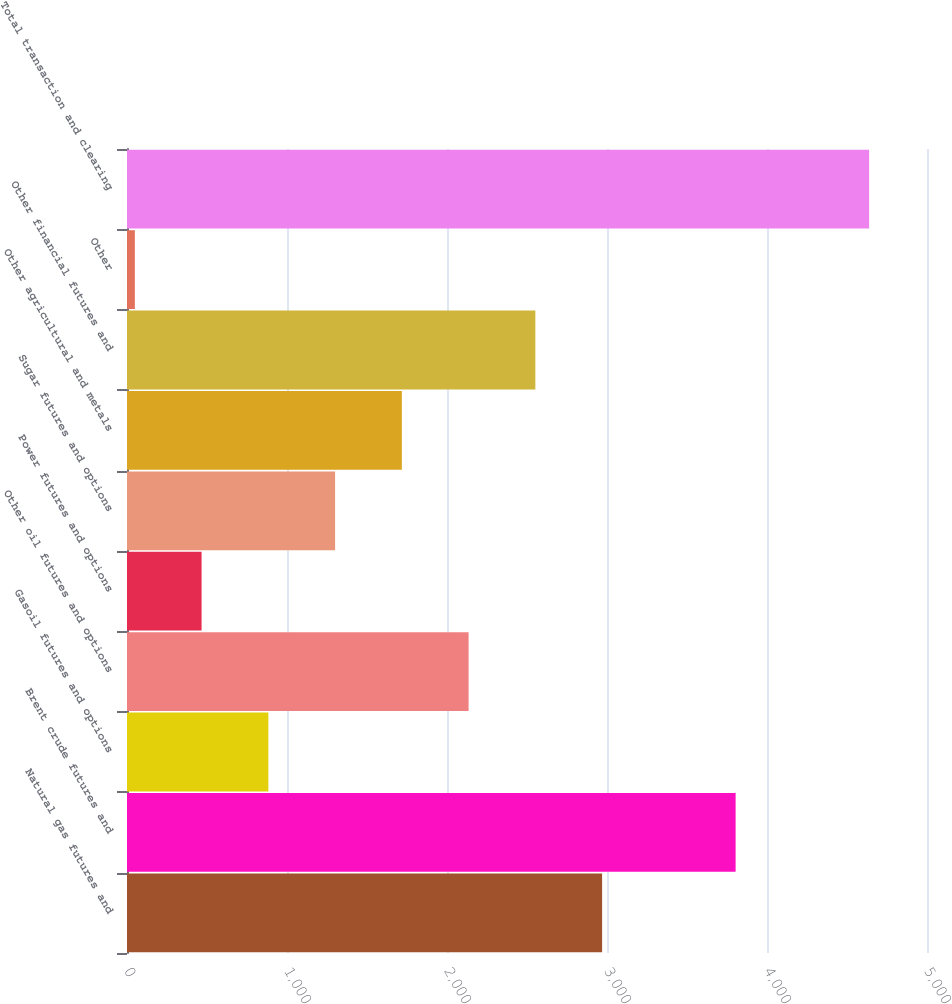Convert chart. <chart><loc_0><loc_0><loc_500><loc_500><bar_chart><fcel>Natural gas futures and<fcel>Brent crude futures and<fcel>Gasoil futures and options<fcel>Other oil futures and options<fcel>Power futures and options<fcel>Sugar futures and options<fcel>Other agricultural and metals<fcel>Other financial futures and<fcel>Other<fcel>Total transaction and clearing<nl><fcel>2969.4<fcel>3803.8<fcel>883.4<fcel>2135<fcel>466.2<fcel>1300.6<fcel>1717.8<fcel>2552.2<fcel>49<fcel>4638.2<nl></chart> 